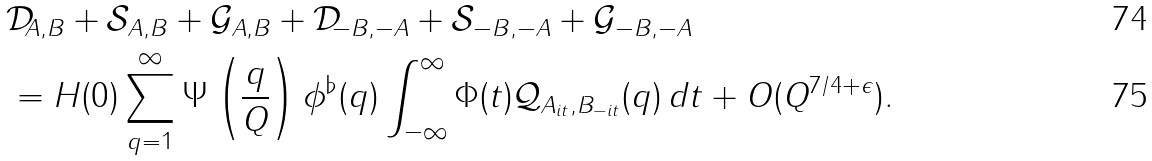Convert formula to latex. <formula><loc_0><loc_0><loc_500><loc_500>& \mathcal { D } _ { A , B } + \mathcal { S } _ { A , B } + \mathcal { G } _ { A , B } + \mathcal { D } _ { - B , - A } + \mathcal { S } _ { - B , - A } + \mathcal { G } _ { - B , - A } \\ & = H ( 0 ) \sum _ { q = 1 } ^ { \infty } \Psi \left ( \frac { q } { Q } \right ) \phi ^ { \flat } ( q ) \int _ { - \infty } ^ { \infty } \Phi ( t ) \mathcal { Q } _ { A _ { i t } , B _ { - i t } } ( q ) \, d t + O ( Q ^ { 7 / 4 + \epsilon } ) .</formula> 